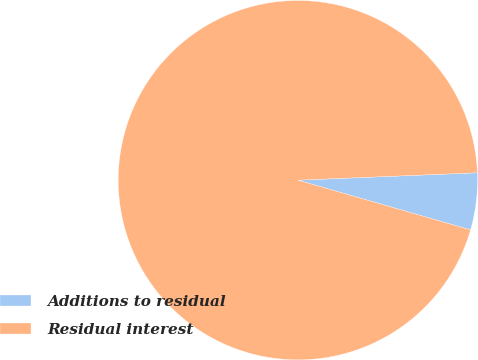<chart> <loc_0><loc_0><loc_500><loc_500><pie_chart><fcel>Additions to residual<fcel>Residual interest<nl><fcel>5.12%<fcel>94.88%<nl></chart> 